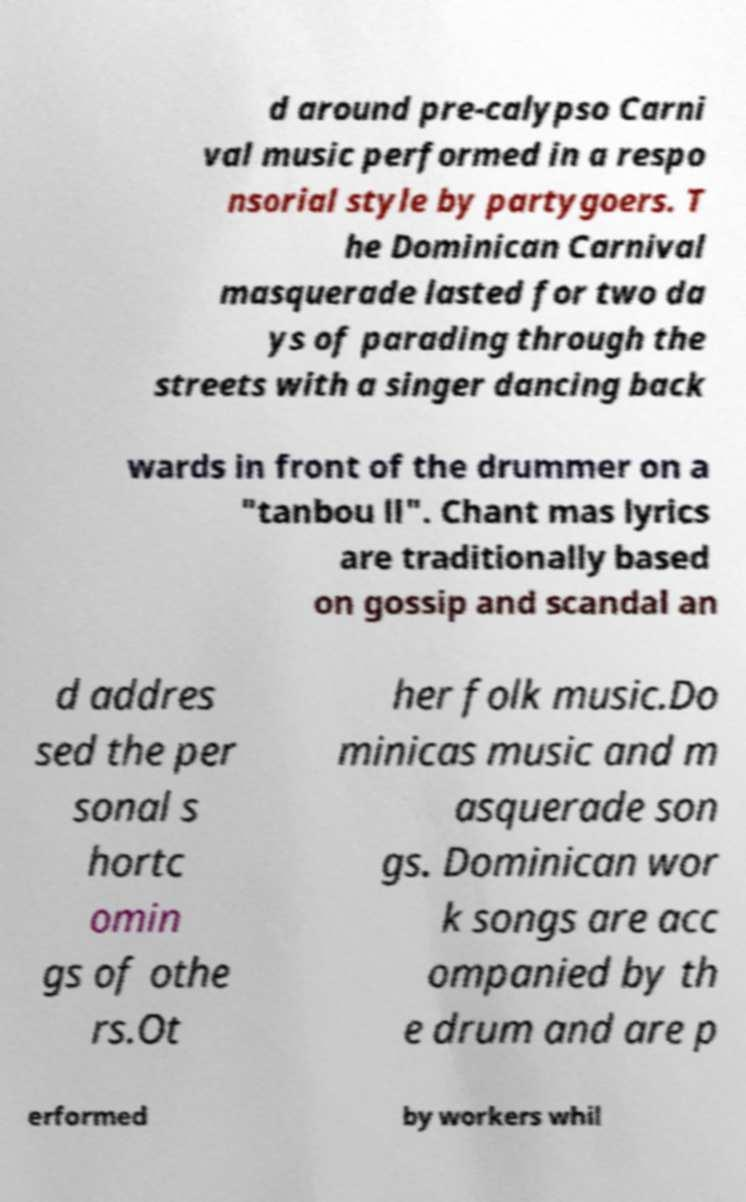I need the written content from this picture converted into text. Can you do that? d around pre-calypso Carni val music performed in a respo nsorial style by partygoers. T he Dominican Carnival masquerade lasted for two da ys of parading through the streets with a singer dancing back wards in front of the drummer on a "tanbou ll". Chant mas lyrics are traditionally based on gossip and scandal an d addres sed the per sonal s hortc omin gs of othe rs.Ot her folk music.Do minicas music and m asquerade son gs. Dominican wor k songs are acc ompanied by th e drum and are p erformed by workers whil 